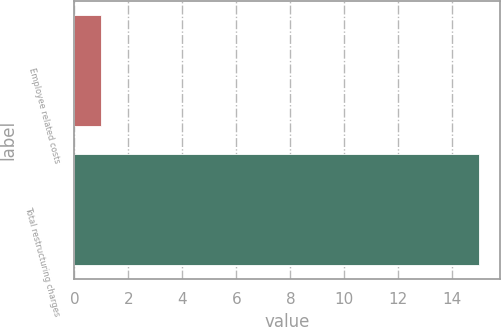Convert chart. <chart><loc_0><loc_0><loc_500><loc_500><bar_chart><fcel>Employee related costs<fcel>Total restructuring charges<nl><fcel>1<fcel>15<nl></chart> 